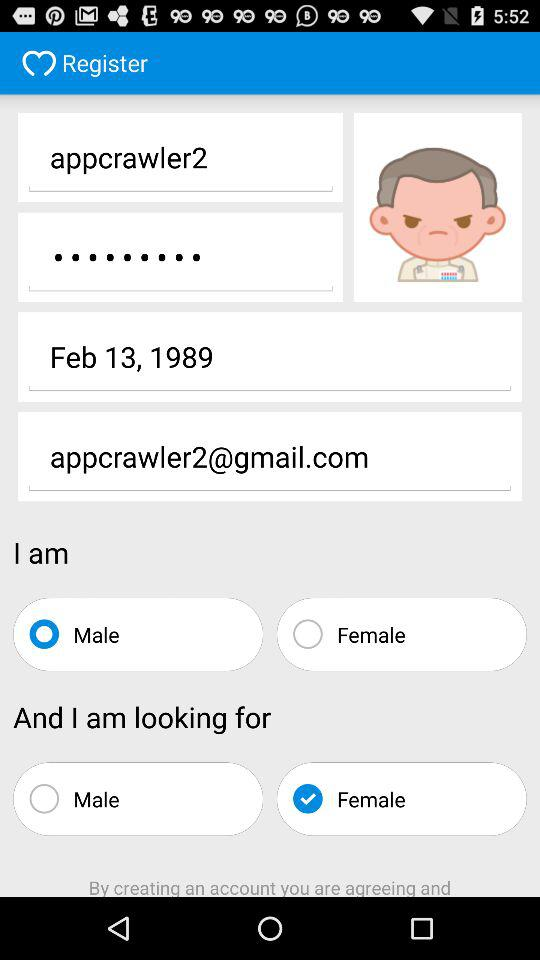What Gmail address is used? The used Gmail address is appcrawler2@gmail.com. 